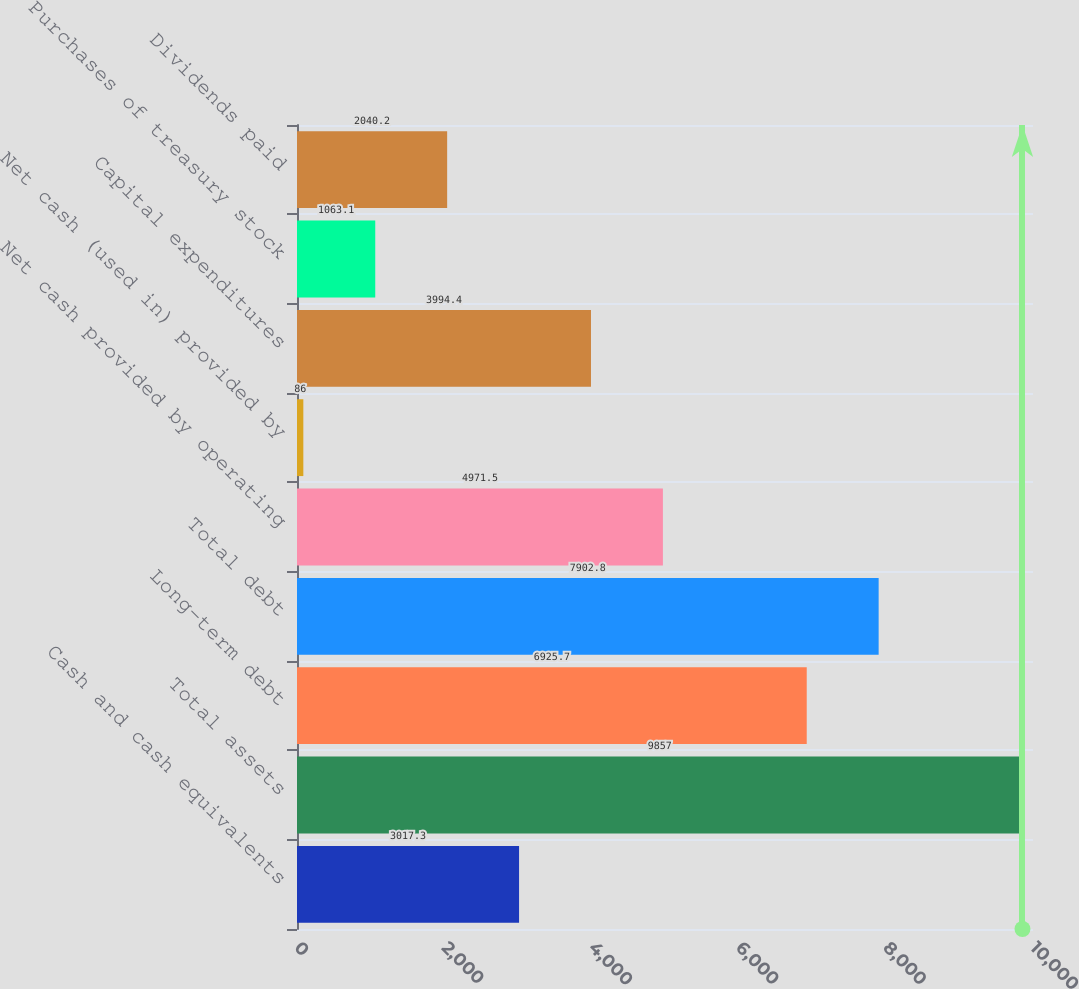Convert chart to OTSL. <chart><loc_0><loc_0><loc_500><loc_500><bar_chart><fcel>Cash and cash equivalents<fcel>Total assets<fcel>Long-term debt<fcel>Total debt<fcel>Net cash provided by operating<fcel>Net cash (used in) provided by<fcel>Capital expenditures<fcel>Purchases of treasury stock<fcel>Dividends paid<nl><fcel>3017.3<fcel>9857<fcel>6925.7<fcel>7902.8<fcel>4971.5<fcel>86<fcel>3994.4<fcel>1063.1<fcel>2040.2<nl></chart> 